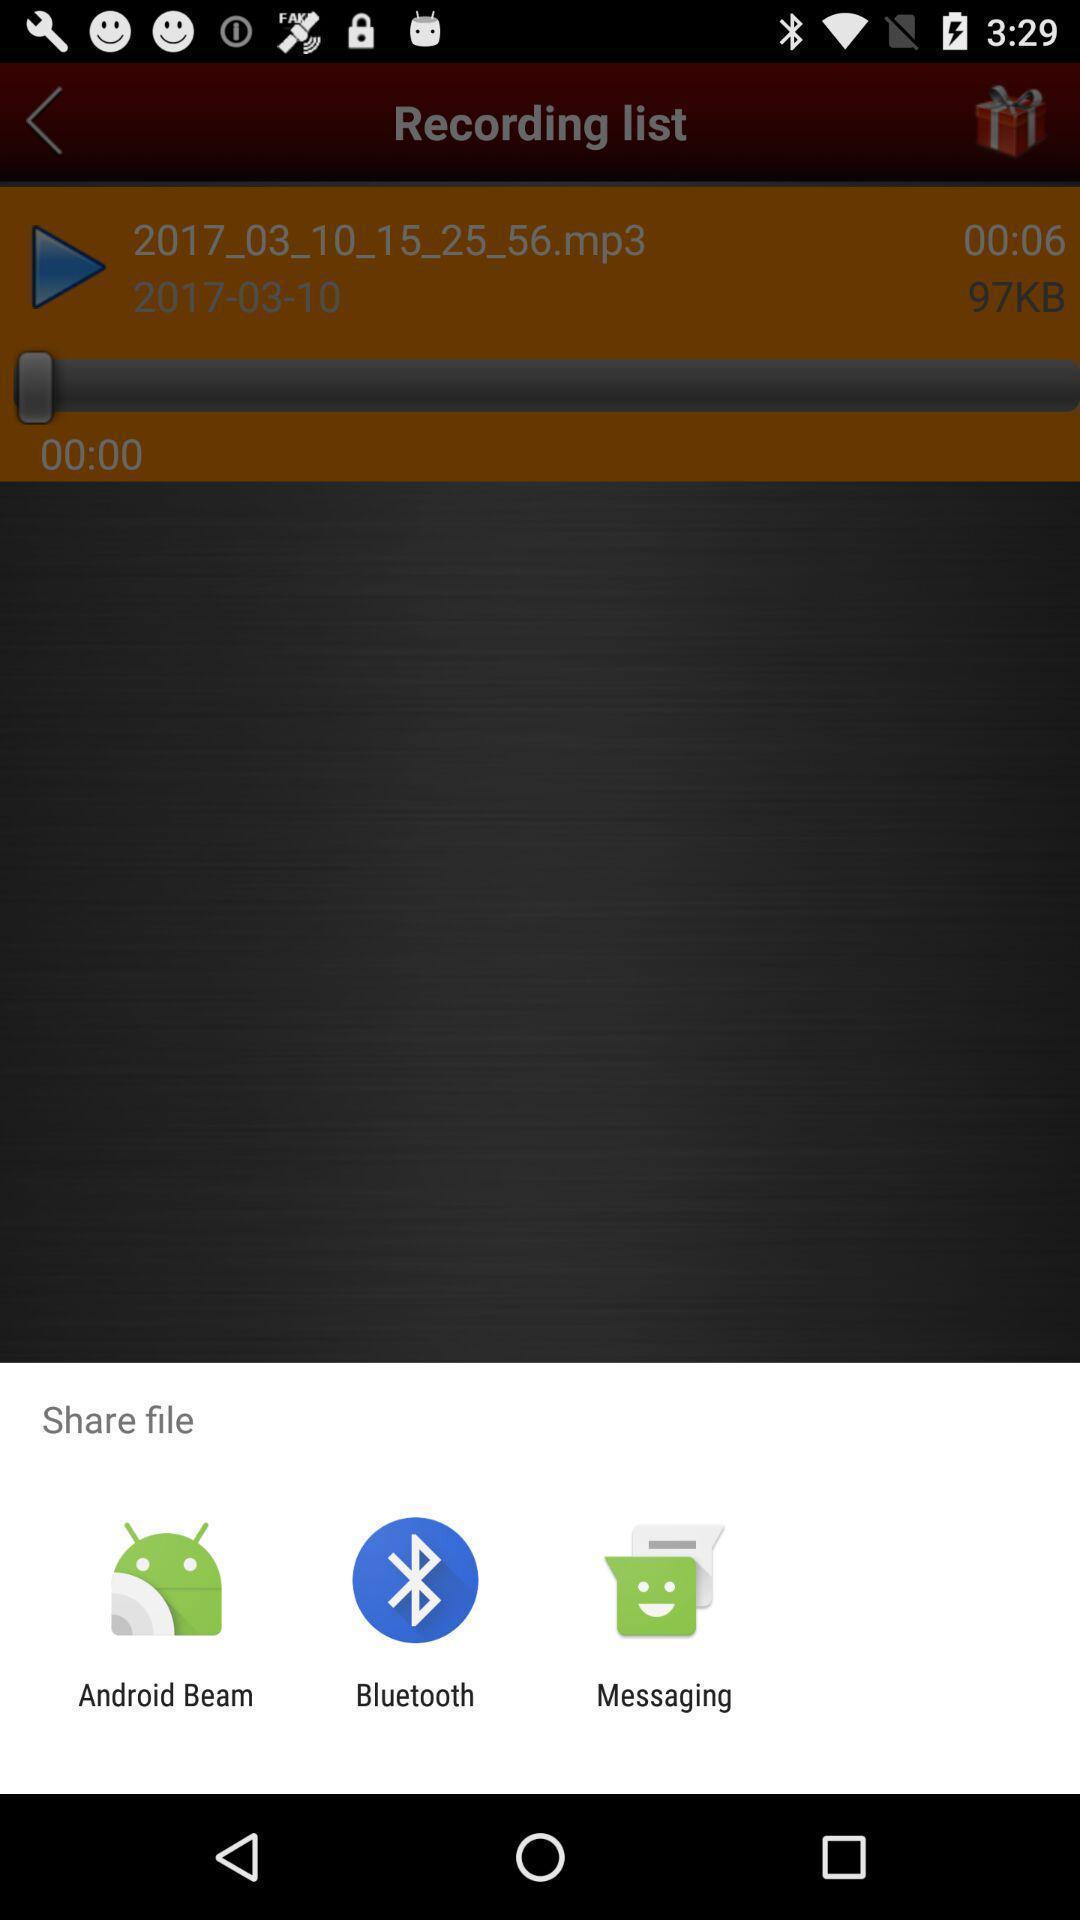Tell me about the visual elements in this screen capture. Popup to share file with options in the voice app. 